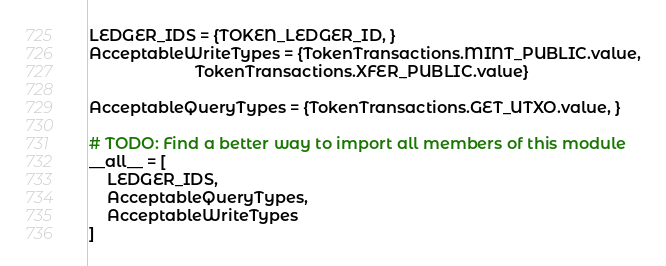Convert code to text. <code><loc_0><loc_0><loc_500><loc_500><_Python_>
LEDGER_IDS = {TOKEN_LEDGER_ID, }
AcceptableWriteTypes = {TokenTransactions.MINT_PUBLIC.value,
                        TokenTransactions.XFER_PUBLIC.value}

AcceptableQueryTypes = {TokenTransactions.GET_UTXO.value, }

# TODO: Find a better way to import all members of this module
__all__ = [
    LEDGER_IDS,
    AcceptableQueryTypes,
    AcceptableWriteTypes
]
</code> 